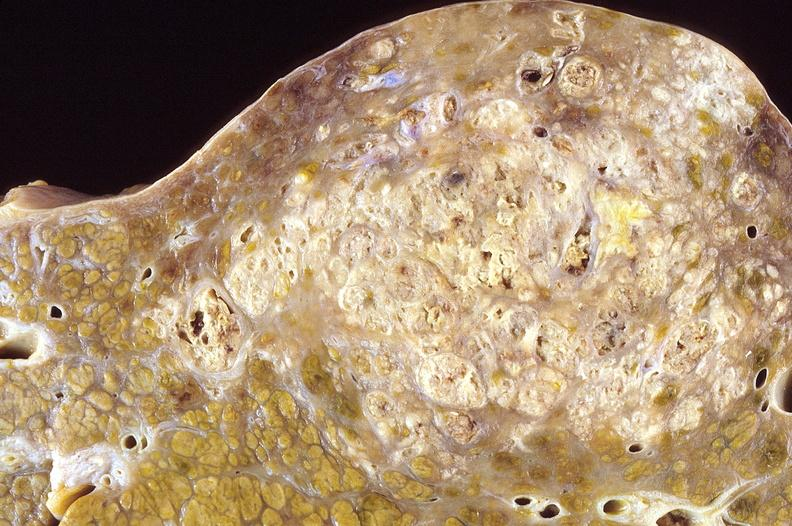s hepatobiliary present?
Answer the question using a single word or phrase. Yes 